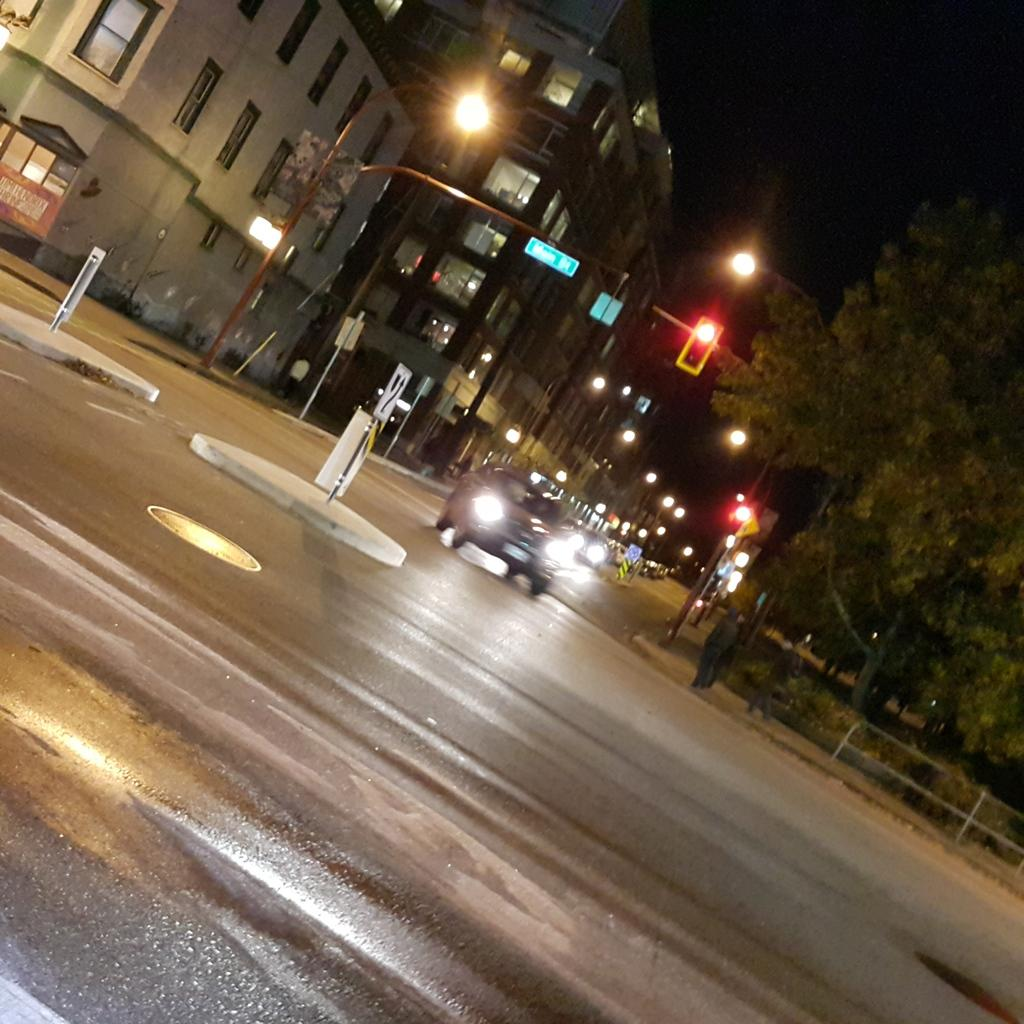What can be seen in the center of the image? There are vehicles on the road in the center of the image. What is visible in the background of the image? In the background, there are name boards, sign boards, lights, trees, and buildings. Can you describe the signage in the background? Yes, there are both name boards and sign boards visible in the background. What type of structures can be seen in the background? Buildings can be seen in the background. Can you tell me how many dogs are tied to the wire in the image? There is no wire or dog present in the image. Is there a horse visible in the image? No, there is no horse visible in the image. 